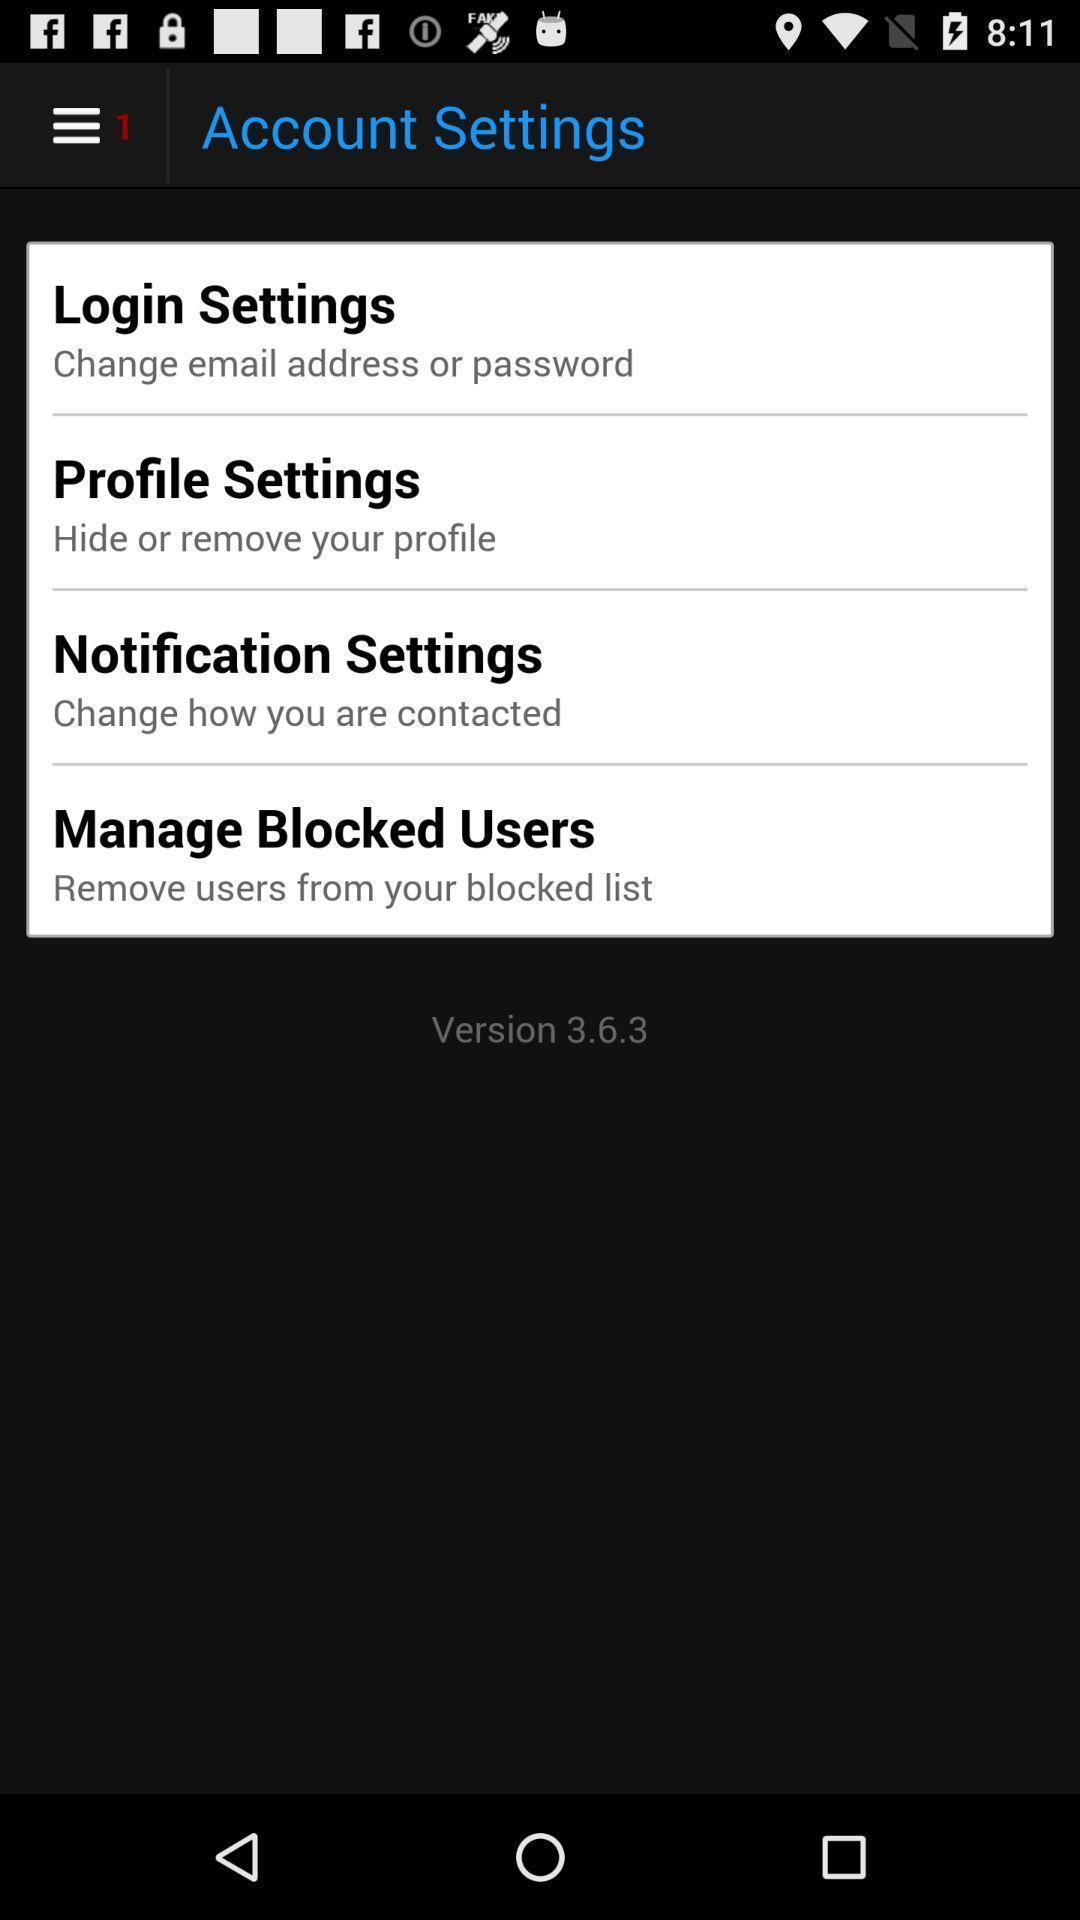Provide a textual representation of this image. Screen displaying multiple options in settings page. 